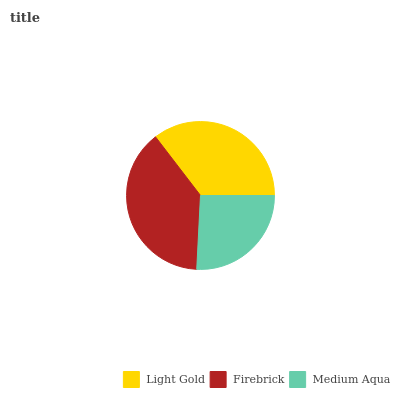Is Medium Aqua the minimum?
Answer yes or no. Yes. Is Firebrick the maximum?
Answer yes or no. Yes. Is Firebrick the minimum?
Answer yes or no. No. Is Medium Aqua the maximum?
Answer yes or no. No. Is Firebrick greater than Medium Aqua?
Answer yes or no. Yes. Is Medium Aqua less than Firebrick?
Answer yes or no. Yes. Is Medium Aqua greater than Firebrick?
Answer yes or no. No. Is Firebrick less than Medium Aqua?
Answer yes or no. No. Is Light Gold the high median?
Answer yes or no. Yes. Is Light Gold the low median?
Answer yes or no. Yes. Is Firebrick the high median?
Answer yes or no. No. Is Firebrick the low median?
Answer yes or no. No. 